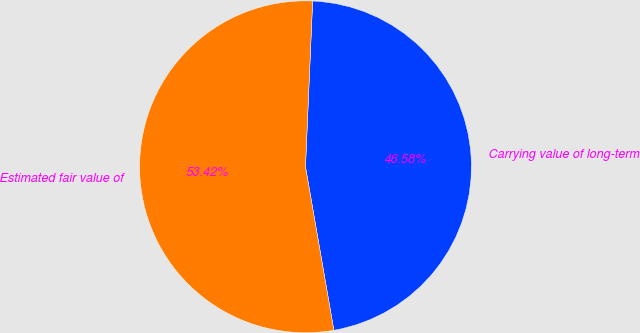Convert chart to OTSL. <chart><loc_0><loc_0><loc_500><loc_500><pie_chart><fcel>Carrying value of long-term<fcel>Estimated fair value of<nl><fcel>46.58%<fcel>53.42%<nl></chart> 